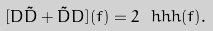Convert formula to latex. <formula><loc_0><loc_0><loc_500><loc_500>[ D \tilde { D } + \tilde { D } D ] ( f ) = 2 \ h h h ( f ) .</formula> 